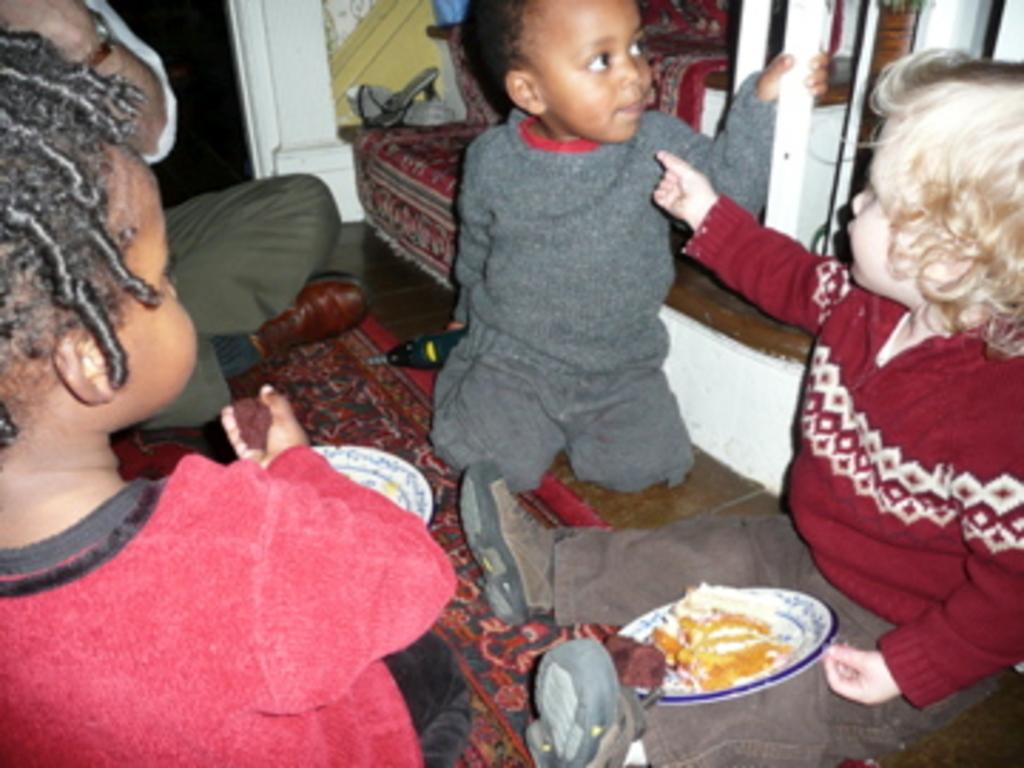In one or two sentences, can you explain what this image depicts? In this picture there are three kids and a person sitting. In the background there is a couch and there other object. In the foreground there is food in the plate. 